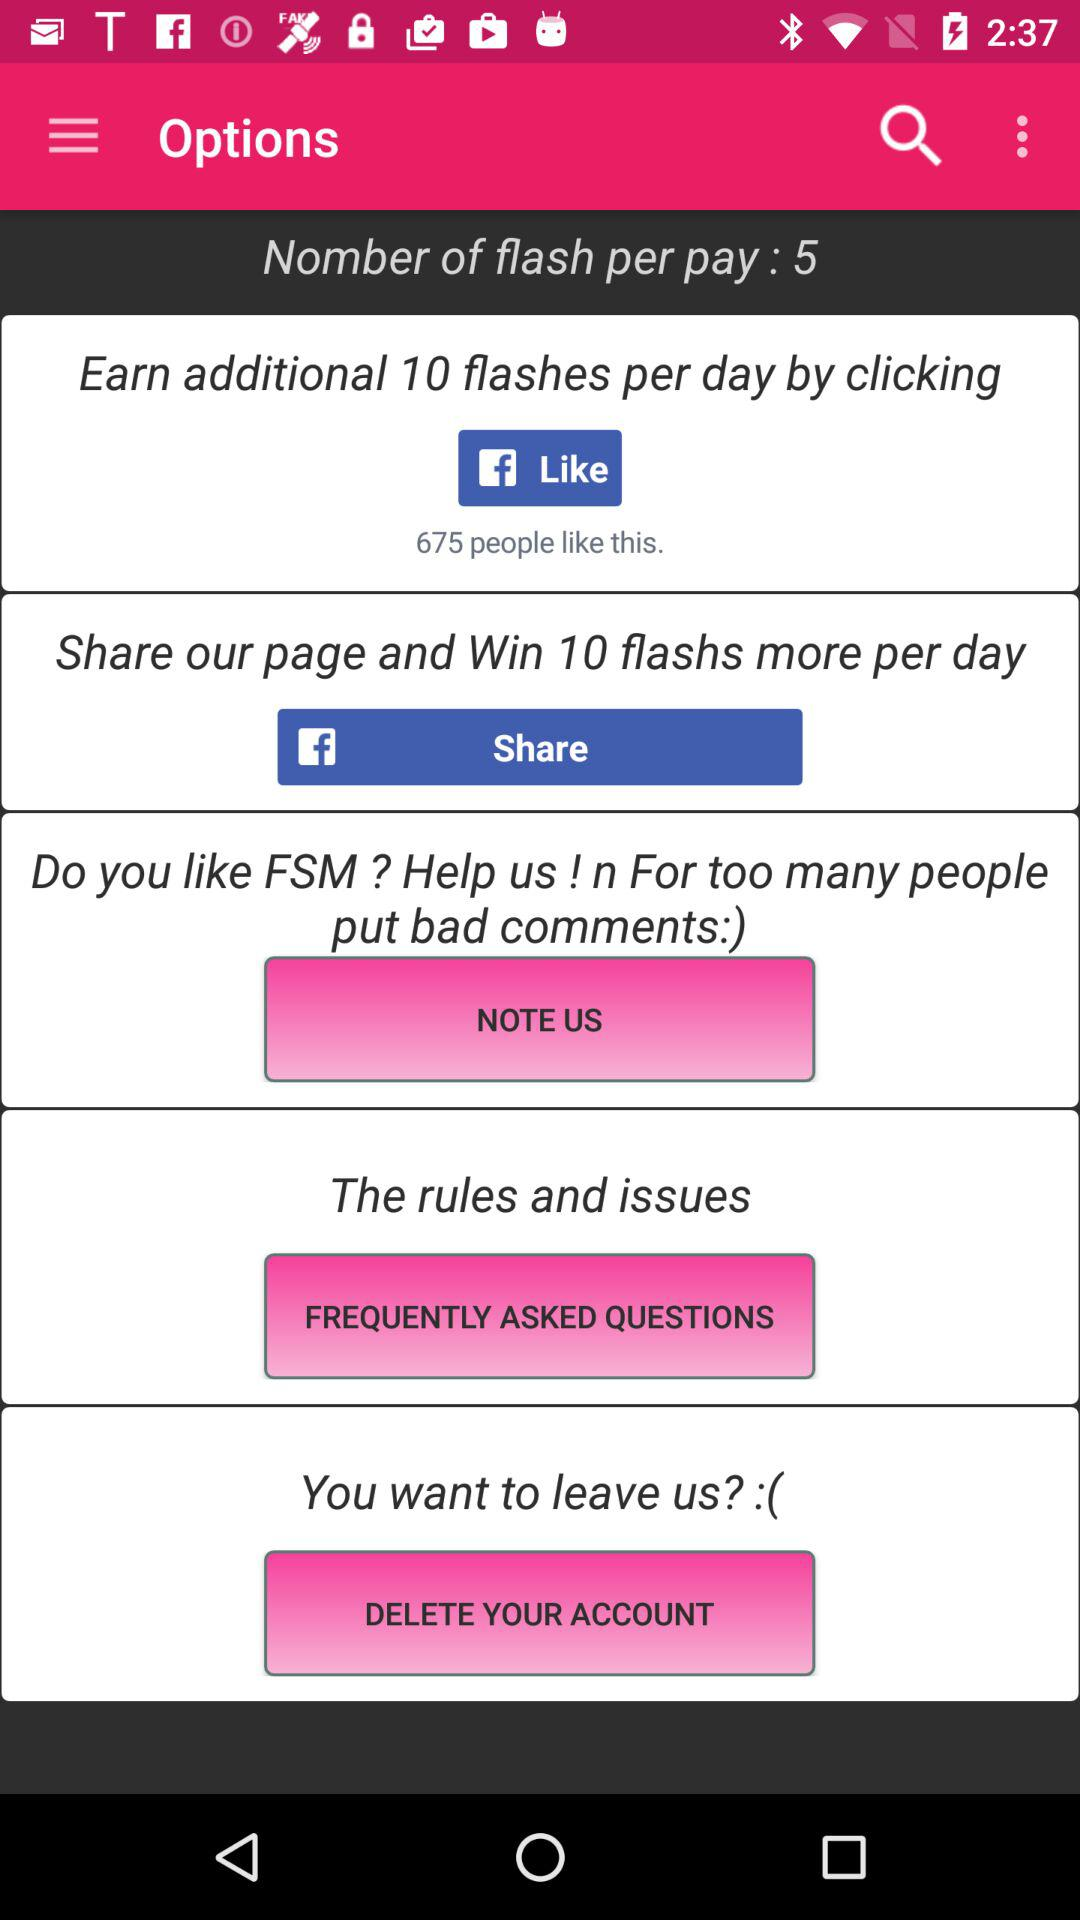How many likes are there? There are 675 likes. 